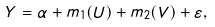Convert formula to latex. <formula><loc_0><loc_0><loc_500><loc_500>Y = \alpha + m _ { 1 } ( U ) + m _ { 2 } ( V ) + \varepsilon ,</formula> 